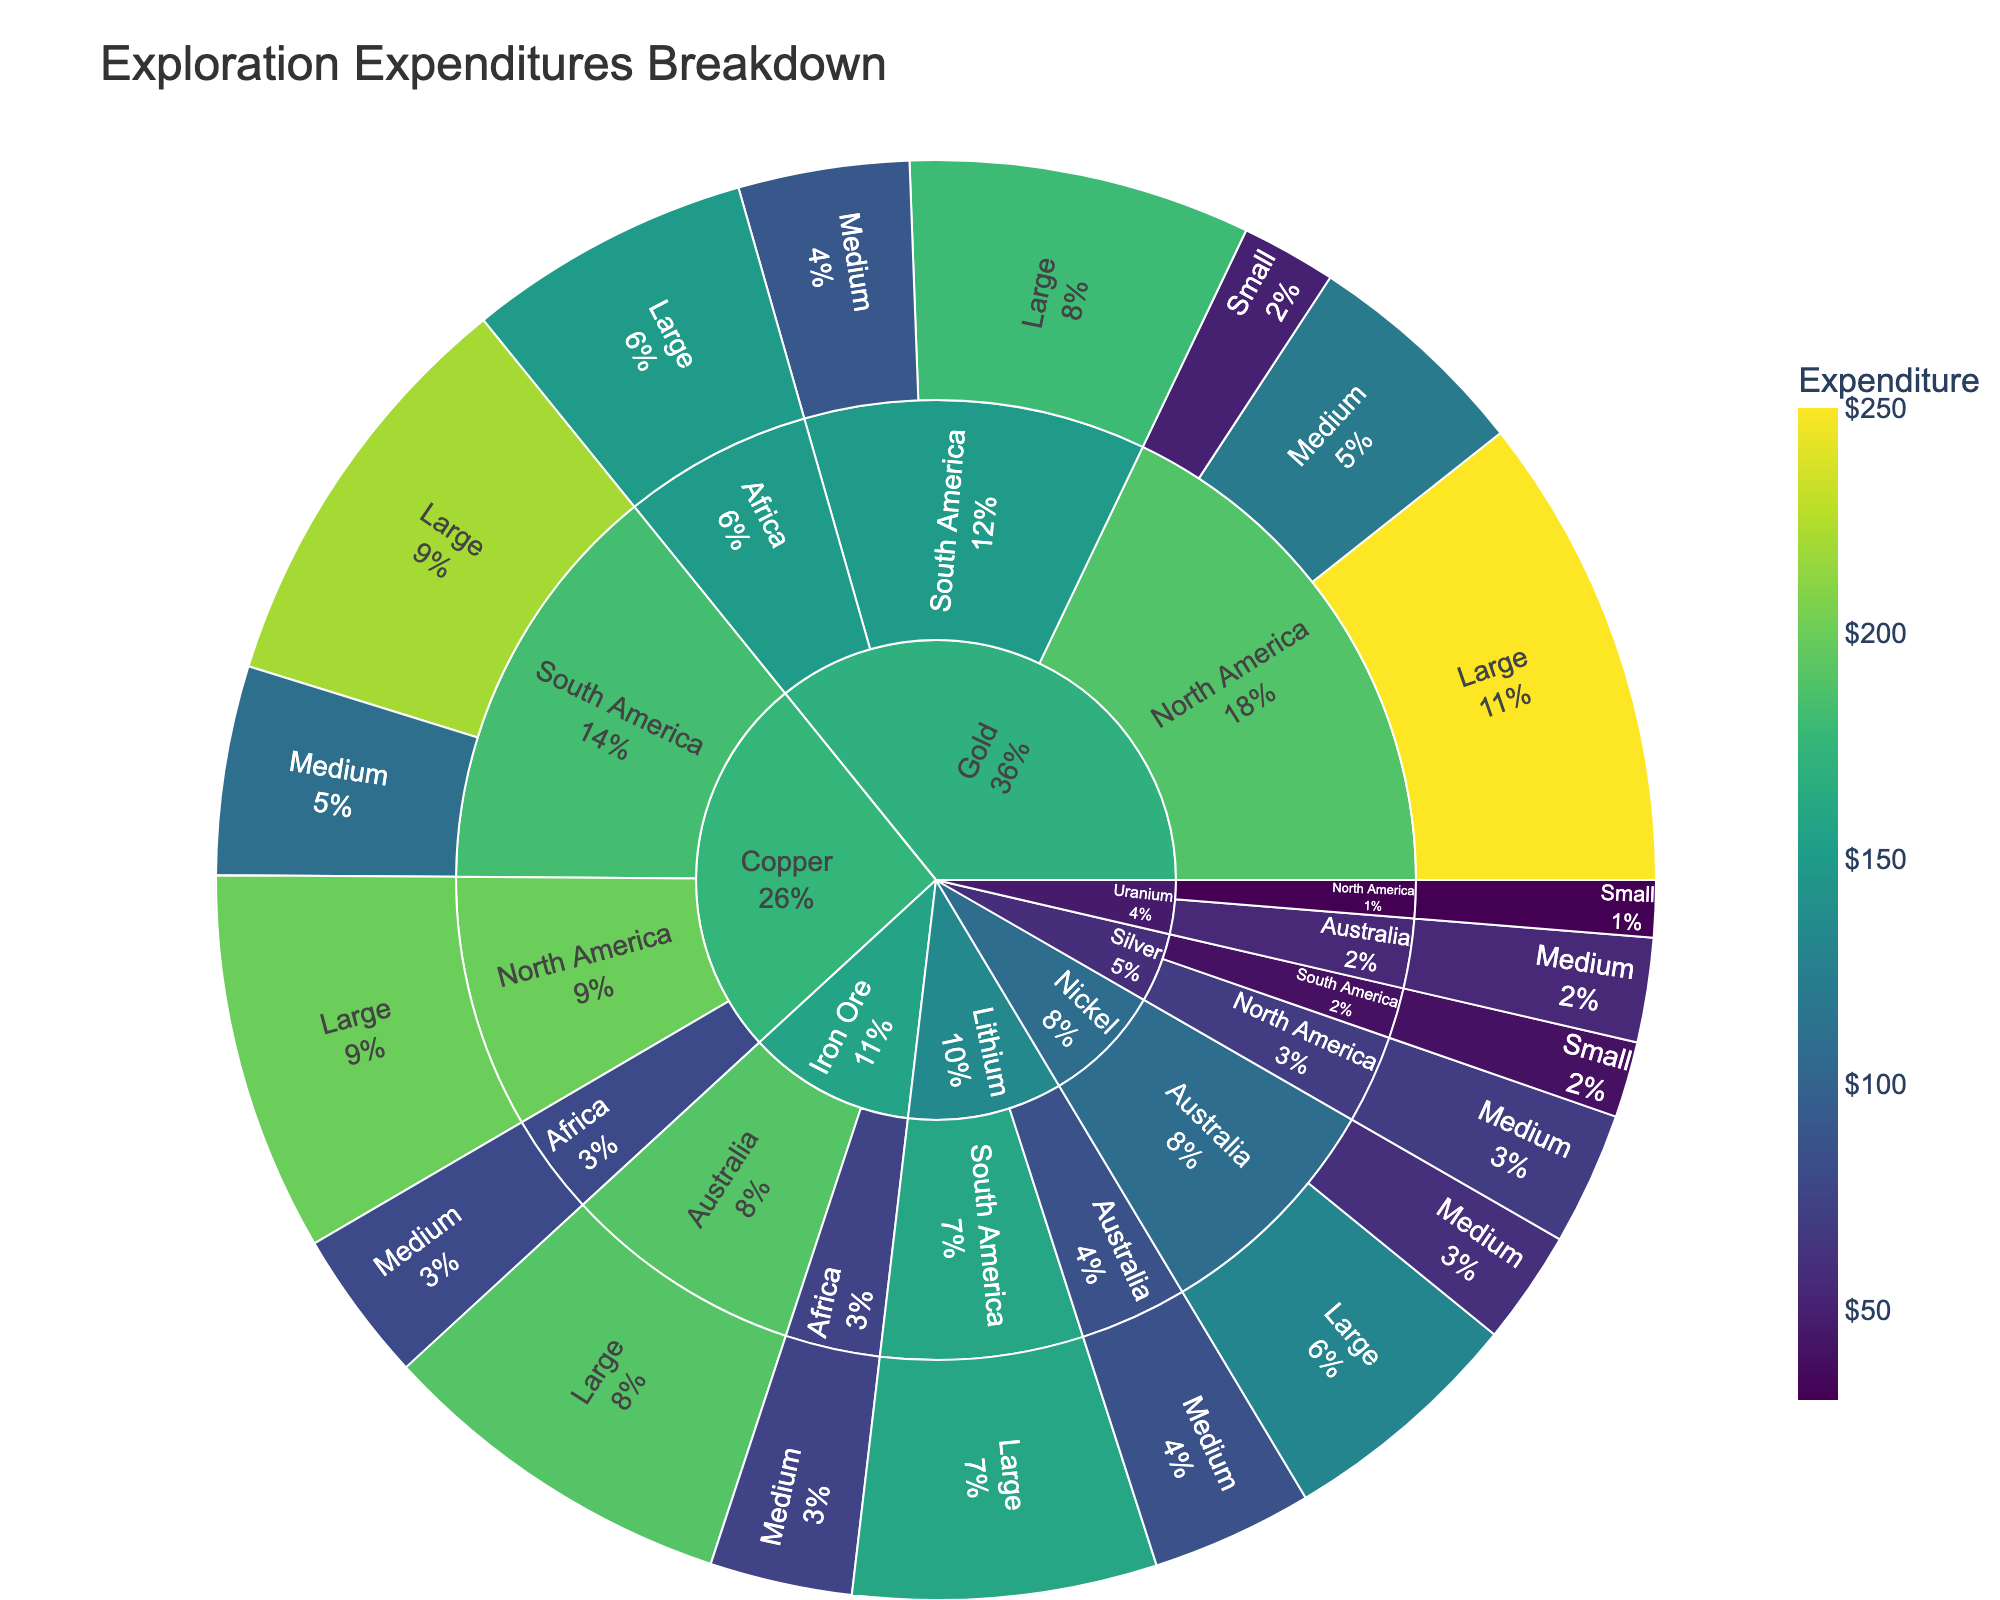What is the title of the figure? The title is usually displayed at the top of the figure, formatted in larger font. In this case, it is "Exploration Expenditures Breakdown."
Answer: Exploration Expenditures Breakdown Which metal shows the highest expenditure in North America? By examining the segments under North America and looking at expenditure values, it can be observed that Gold has the largest share.
Answer: Gold Among the company sizes, which has the highest exploration expenditure for Copper in South America? Drill down into the Copper segment in South America to see the expenditures by company size. Large companies have the highest expenditure.
Answer: Large How does the total exploration expenditure for Gold compare between North America and South America? Sum the expenditures for Gold in North America (250 + 120 + 50) and in South America (180 + 90). North America has a total of 420, and South America has a total of 270. Therefore, North America's expenditure is higher.
Answer: North America Which region has the highest total expenditure for Nickel? Observe the Nickel segments in different regions. Sum up the expenditures for each region. In Australia, the expenditure for Nickel is 130 (Large) + 60 (Medium) = 190. It is the only region listed, so it has the highest total.
Answer: Australia For which metal does Africa have an expenditure? Check the segments for Africa and see the labeled metals. The metals listed under Africa are Gold, Copper, and Iron Ore.
Answer: Gold, Copper, Iron Ore What percentage of the total exploration expenditure does Lithium have in South America? Find the expenditure for Lithium in South America (160) and divide it by the total expenditure. The total expenditure is the sum of all expenditures (2295). Thus, the percentage is (160/2295) ≈ 6.97%.
Answer: ≈ 6.97% Is the expenditure for Uranium in North America higher or lower than in Australia? Compare the expenditures: Uranium in North America is 30, while in Australia is 55. The expenditure in North America is lower.
Answer: Lower Which region has more diversity in metals based on exploration expenditures, South America or North America? Looking at the regions, South America has expenditures for Gold, Copper, Silver, and Lithium, whereas North America has expenditures for Gold, Copper, Silver, and Uranium. Both have four different metals, so they have equal diversity.
Answer: Equal What is the largest single exploration expenditure recorded, and for which category? Find the highest expenditure value, which is for Gold in North America (Large company size) with an expenditure of 250.
Answer: Gold in North America (Large) 